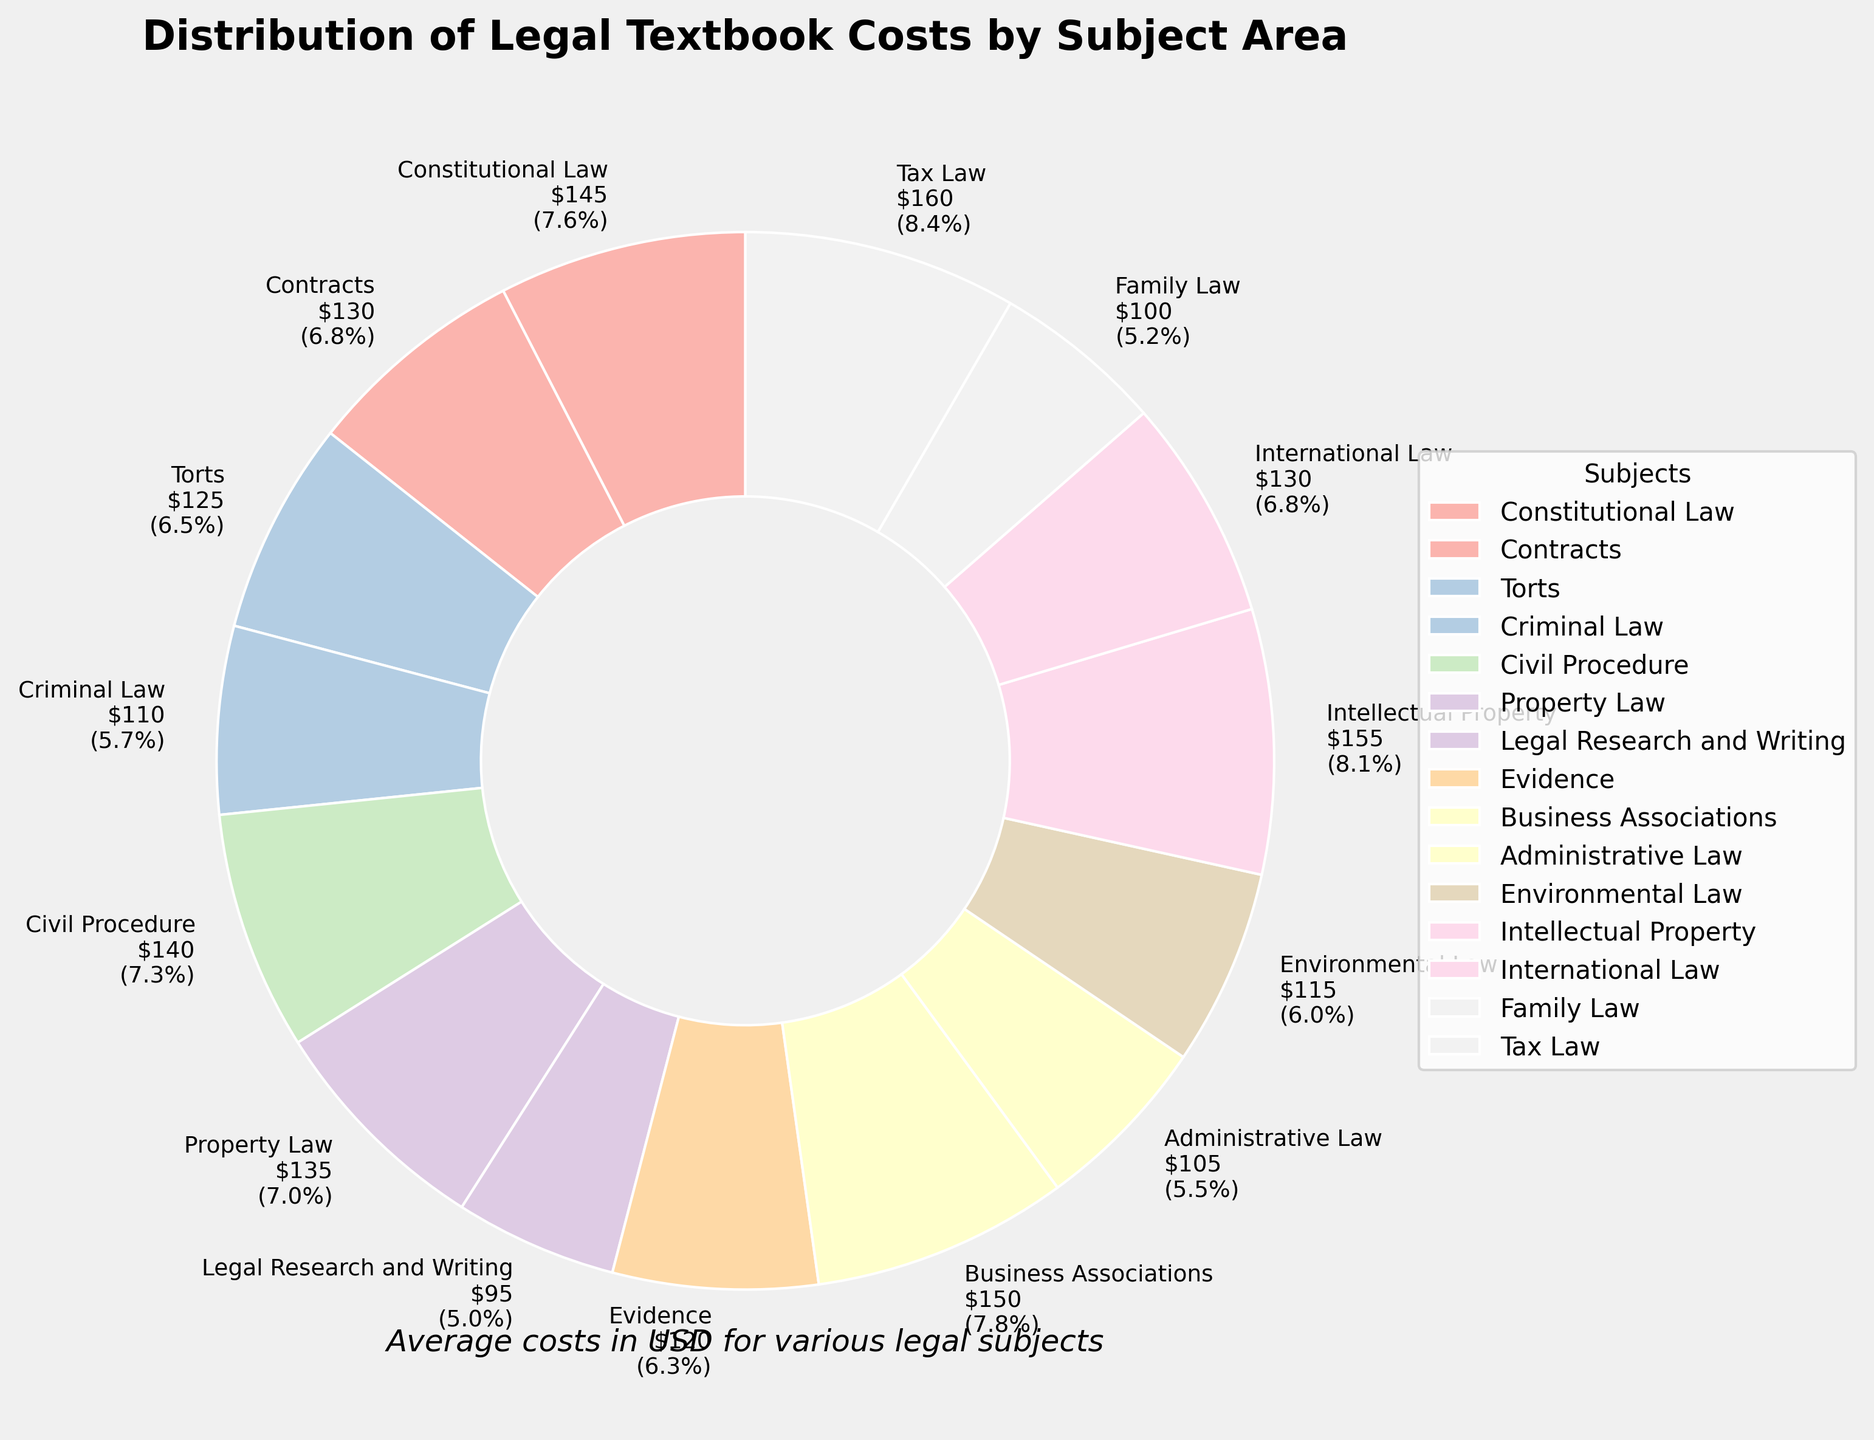What subject has the highest average textbook cost? Scan through the labels to find the highest dollar amount. Intellectual Property has the highest average cost of $155.
Answer: Intellectual Property What subject has the lowest average textbook cost? Look for the label with the lowest dollar amount. Legal Research and Writing has the lowest average cost of $95.
Answer: Legal Research and Writing What is the total percentage of costs for Constitutional Law, Contracts, and Torts combined? Find the percentages for Constitutional Law (145), Contracts (130), and Torts (125). Calculate their total: (145 + 130 + 125) / Total Cost * 100. The total is ((145 + 130 + 125) / 1855) * 100 ≈ 21.1%.
Answer: 21.1% How does the cost of textbooks for Criminal Law compare to Administrative Law? Compare $110 for Criminal Law with $105 for Administrative Law. Criminal Law is slightly more expensive at $110.
Answer: Criminal Law costs more Which subject is costlier, Family Law or Environmental Law? Compare the labels. Environmental Law costs $115 whereas Family Law costs $100. Environmental Law is costlier.
Answer: Environmental Law costs more Which three subjects have the highest average textbook costs? Identify the three highest amounts: Intellectual Property ($155), Tax Law ($160), and Business Associations ($150).
Answer: Tax Law, Intellectual Property, Business Associations What is the combined cost of textbooks for Civil Procedure, Property Law, and Family Law? Add the costs for these subjects: 140 (Civil Procedure) + 135 (Property Law) + 100 (Family Law) = $375.
Answer: $375 What is the percentage difference between the highest (Tax Law) and the lowest (Legal Research and Writing) costs? Calculate the difference: $160 (Tax Law) - $95 (Legal Research and Writing) = $65. Convert it to percentage of the lower cost: ($65 / $95) * 100 ≈ 68.4%.
Answer: 68.4% Which subject has nearly the same average cost as International Law? Find a subject whose cost is close to International Law's $130. Both Contracts and International Law have $130.
Answer: Contracts What is the average cost of textbooks for Constitutional Law, Evidence, and Criminal Law? Find the average cost: (145 + 120 + 110) / 3 = 375 / 3 ≈ $125.
Answer: $125 